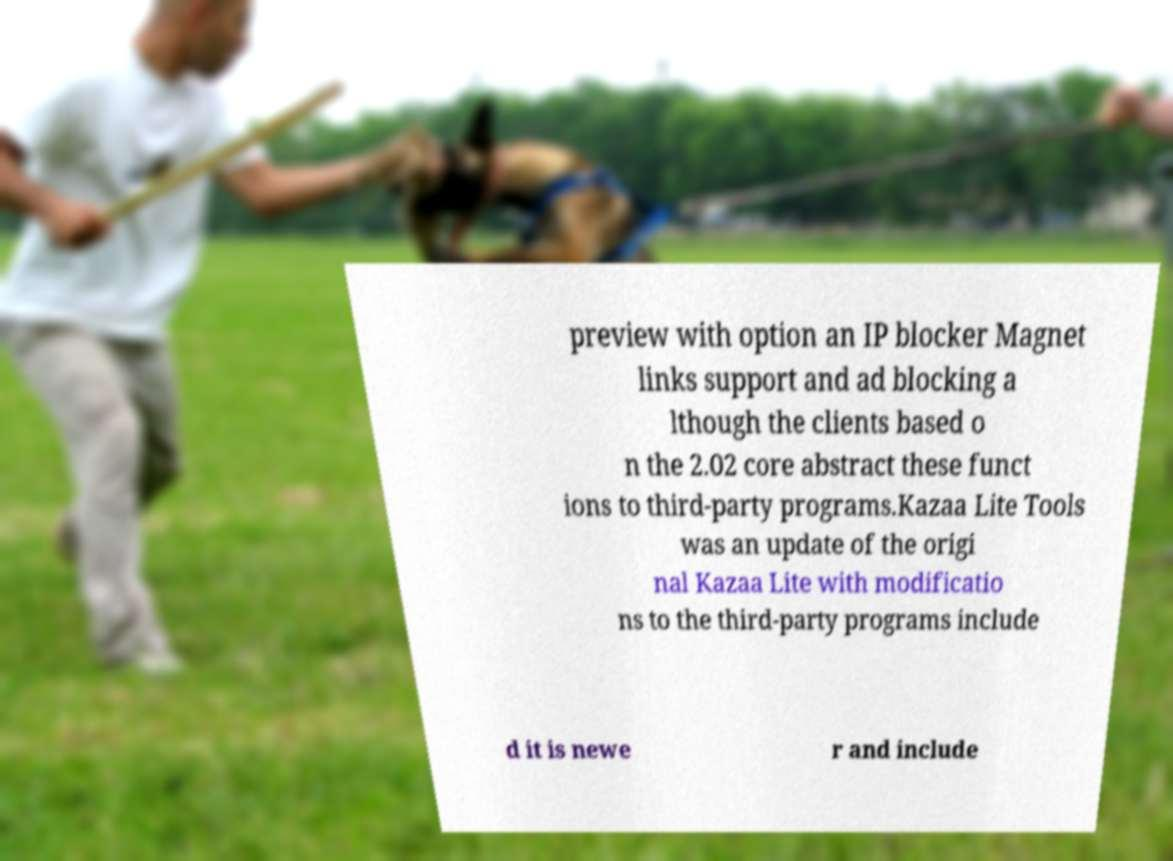There's text embedded in this image that I need extracted. Can you transcribe it verbatim? preview with option an IP blocker Magnet links support and ad blocking a lthough the clients based o n the 2.02 core abstract these funct ions to third-party programs.Kazaa Lite Tools was an update of the origi nal Kazaa Lite with modificatio ns to the third-party programs include d it is newe r and include 